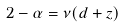Convert formula to latex. <formula><loc_0><loc_0><loc_500><loc_500>2 - \alpha = \nu ( d + z )</formula> 